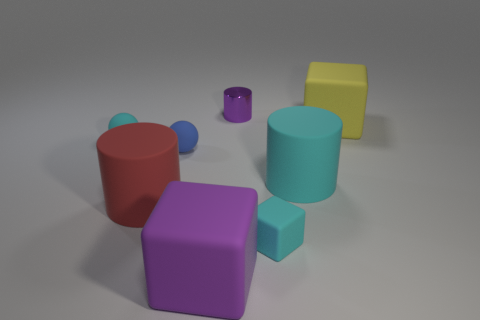Subtract all cyan cylinders. How many cylinders are left? 2 Subtract all cyan cylinders. How many cylinders are left? 2 Subtract all spheres. How many objects are left? 6 Subtract 1 cubes. How many cubes are left? 2 Subtract all cyan cylinders. How many cyan cubes are left? 1 Add 2 big brown balls. How many objects exist? 10 Subtract 0 green blocks. How many objects are left? 8 Subtract all gray blocks. Subtract all cyan cylinders. How many blocks are left? 3 Subtract all tiny metal objects. Subtract all yellow objects. How many objects are left? 6 Add 7 rubber balls. How many rubber balls are left? 9 